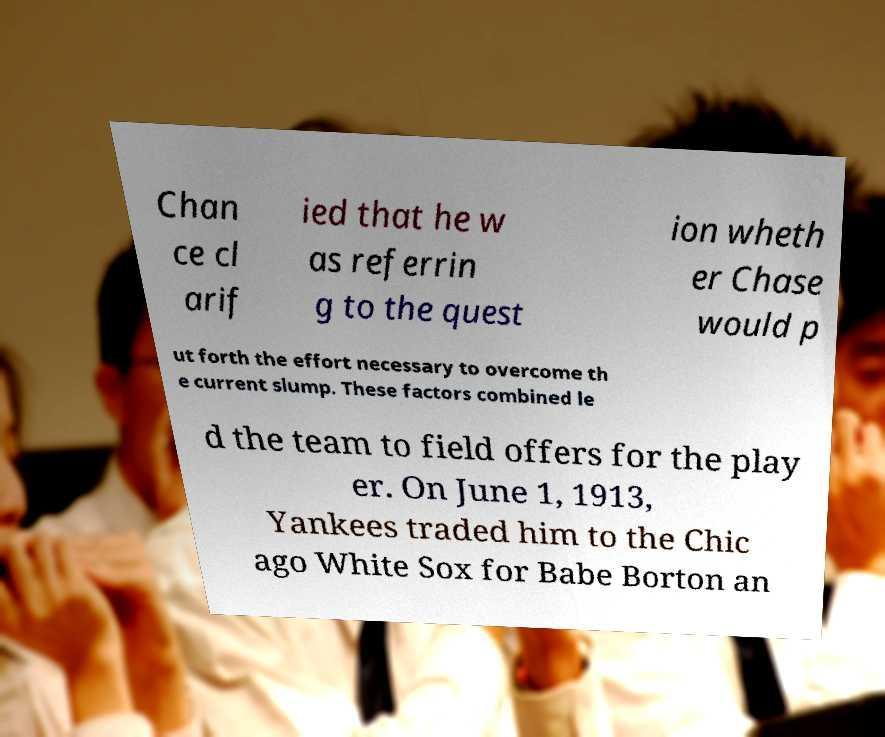Could you extract and type out the text from this image? Chan ce cl arif ied that he w as referrin g to the quest ion wheth er Chase would p ut forth the effort necessary to overcome th e current slump. These factors combined le d the team to field offers for the play er. On June 1, 1913, Yankees traded him to the Chic ago White Sox for Babe Borton an 